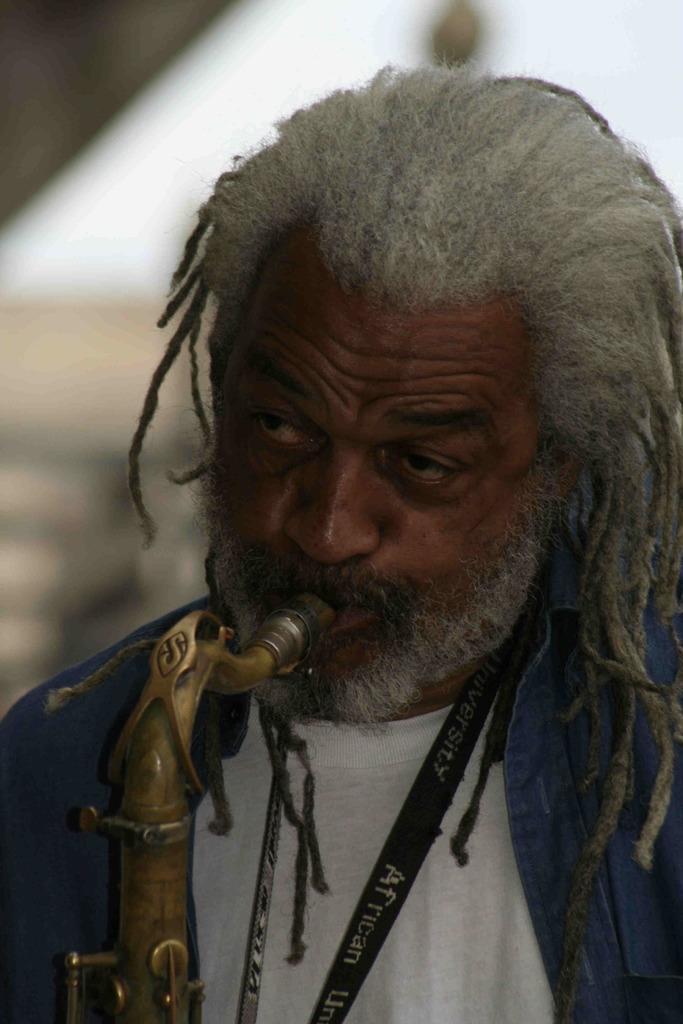How would you summarize this image in a sentence or two? In this picture we can see a person with an object in his mouth and in the background we can see it is blurry. 